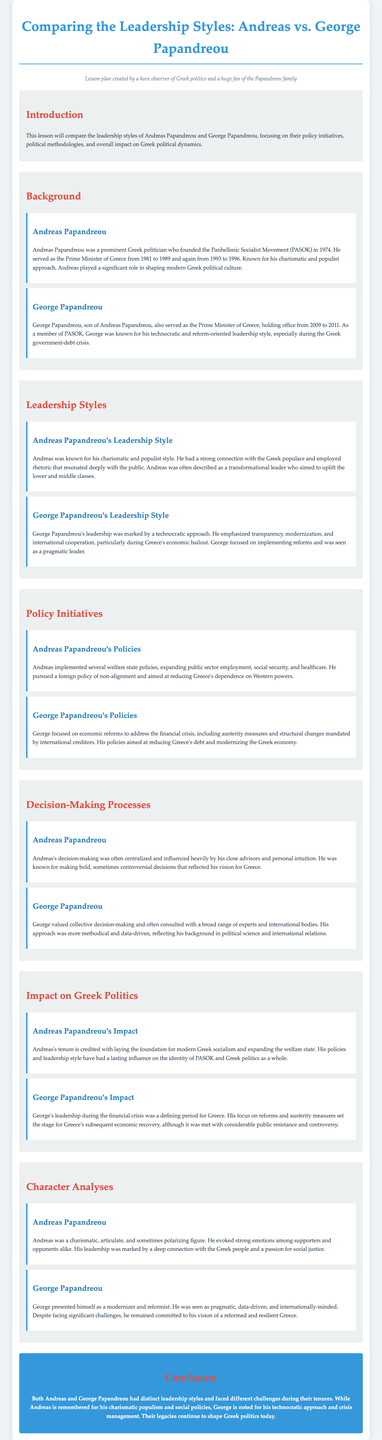What years did Andreas Papandreou serve as Prime Minister? The document states that Andreas Papandreou served as Prime Minister from 1981 to 1989 and again from 1993 to 1996.
Answer: 1981 to 1989 and 1993 to 1996 What is George Papandreou's leadership style known for? The document highlights that George Papandreou's leadership was marked by a technocratic approach, especially during the financial crisis.
Answer: Technocratic approach What was one of Andreas Papandreou’s policy initiatives? The document mentions that Andreas implemented several welfare state policies, including expanding public sector employment.
Answer: Expanding public sector employment Which political party did both Andreas and George Papandreou belong to? The document identifies that both Andreas and George Papandreou were members of the Panhellenic Socialist Movement (PASOK).
Answer: PASOK How did George Papandreou's decision-making process differ from that of Andreas Papandreou? The document states that George valued collective decision-making and consulted a broad range of experts, while Andreas’s was often centralized.
Answer: Collective decision-making What was the period of George Papandreou's premiership? According to the document, George Papandreou served as Prime Minister from 2009 to 2011.
Answer: 2009 to 2011 What character trait is associated with Andreas Papandreou? The document describes Andreas as a charismatic and articulate figure.
Answer: Charismatic What economic approach did George Papandreou emphasize during his leadership? The document indicates that George focused on economic reforms and austerity measures during the financial crisis.
Answer: Economic reforms and austerity measures What was the impact of Andreas Papandreou's leadership on Greek socialism? The document credits Andreas with laying the foundation for modern Greek socialism.
Answer: Foundation for modern Greek socialism 